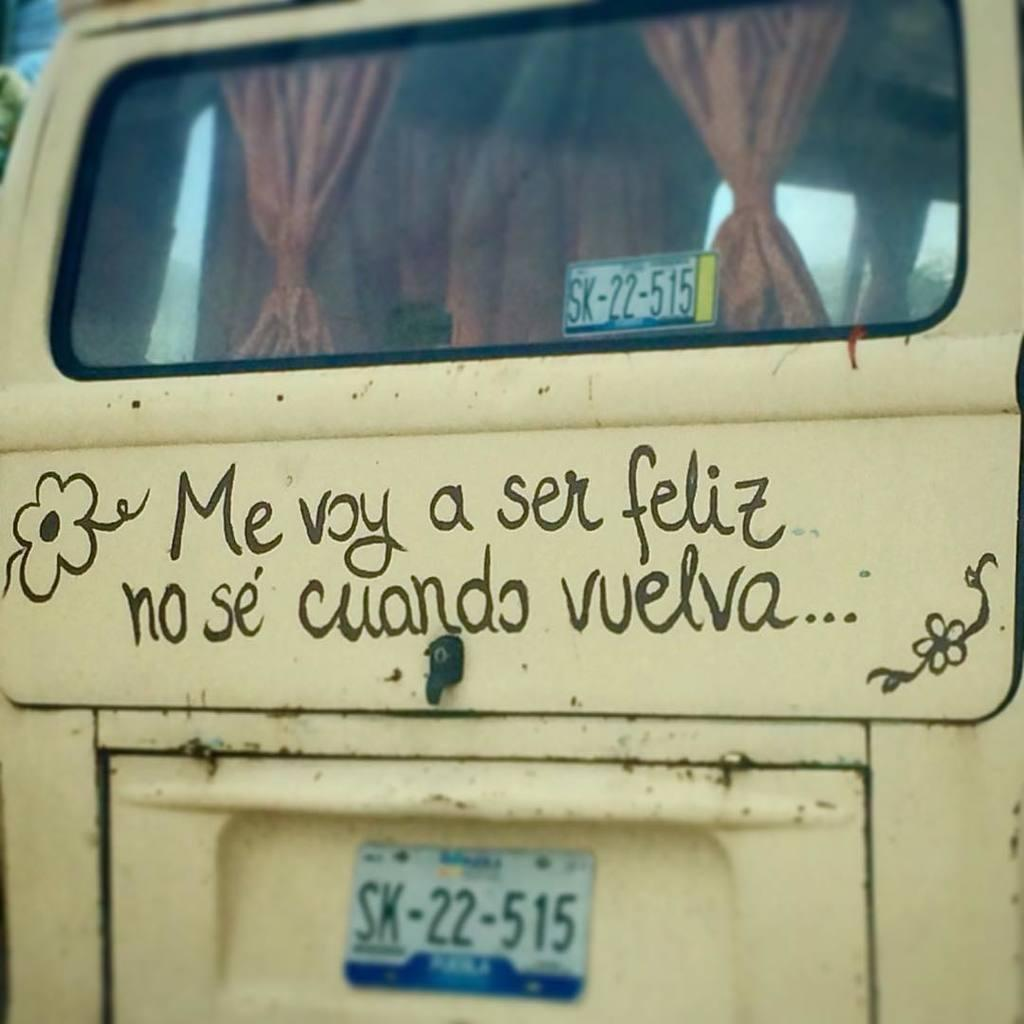What is written or displayed on the vehicle in the image? There is text on the vehicle in the image. Where is the number plate located in the image? The number plate is at the bottom of the image. What type of window treatment can be seen at the top of the image? There are curtains at the top of the image. How many bricks are used to construct the town in the image? There is no town or bricks present in the image. What type of stitch is used to create the curtains in the image? The image does not provide information about the type of stitch used for the curtains. 